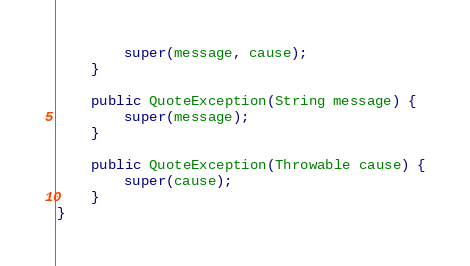Convert code to text. <code><loc_0><loc_0><loc_500><loc_500><_Java_>		super(message, cause);
	}

	public QuoteException(String message) {
		super(message);
	}

	public QuoteException(Throwable cause) {
		super(cause);
	}
}
</code> 